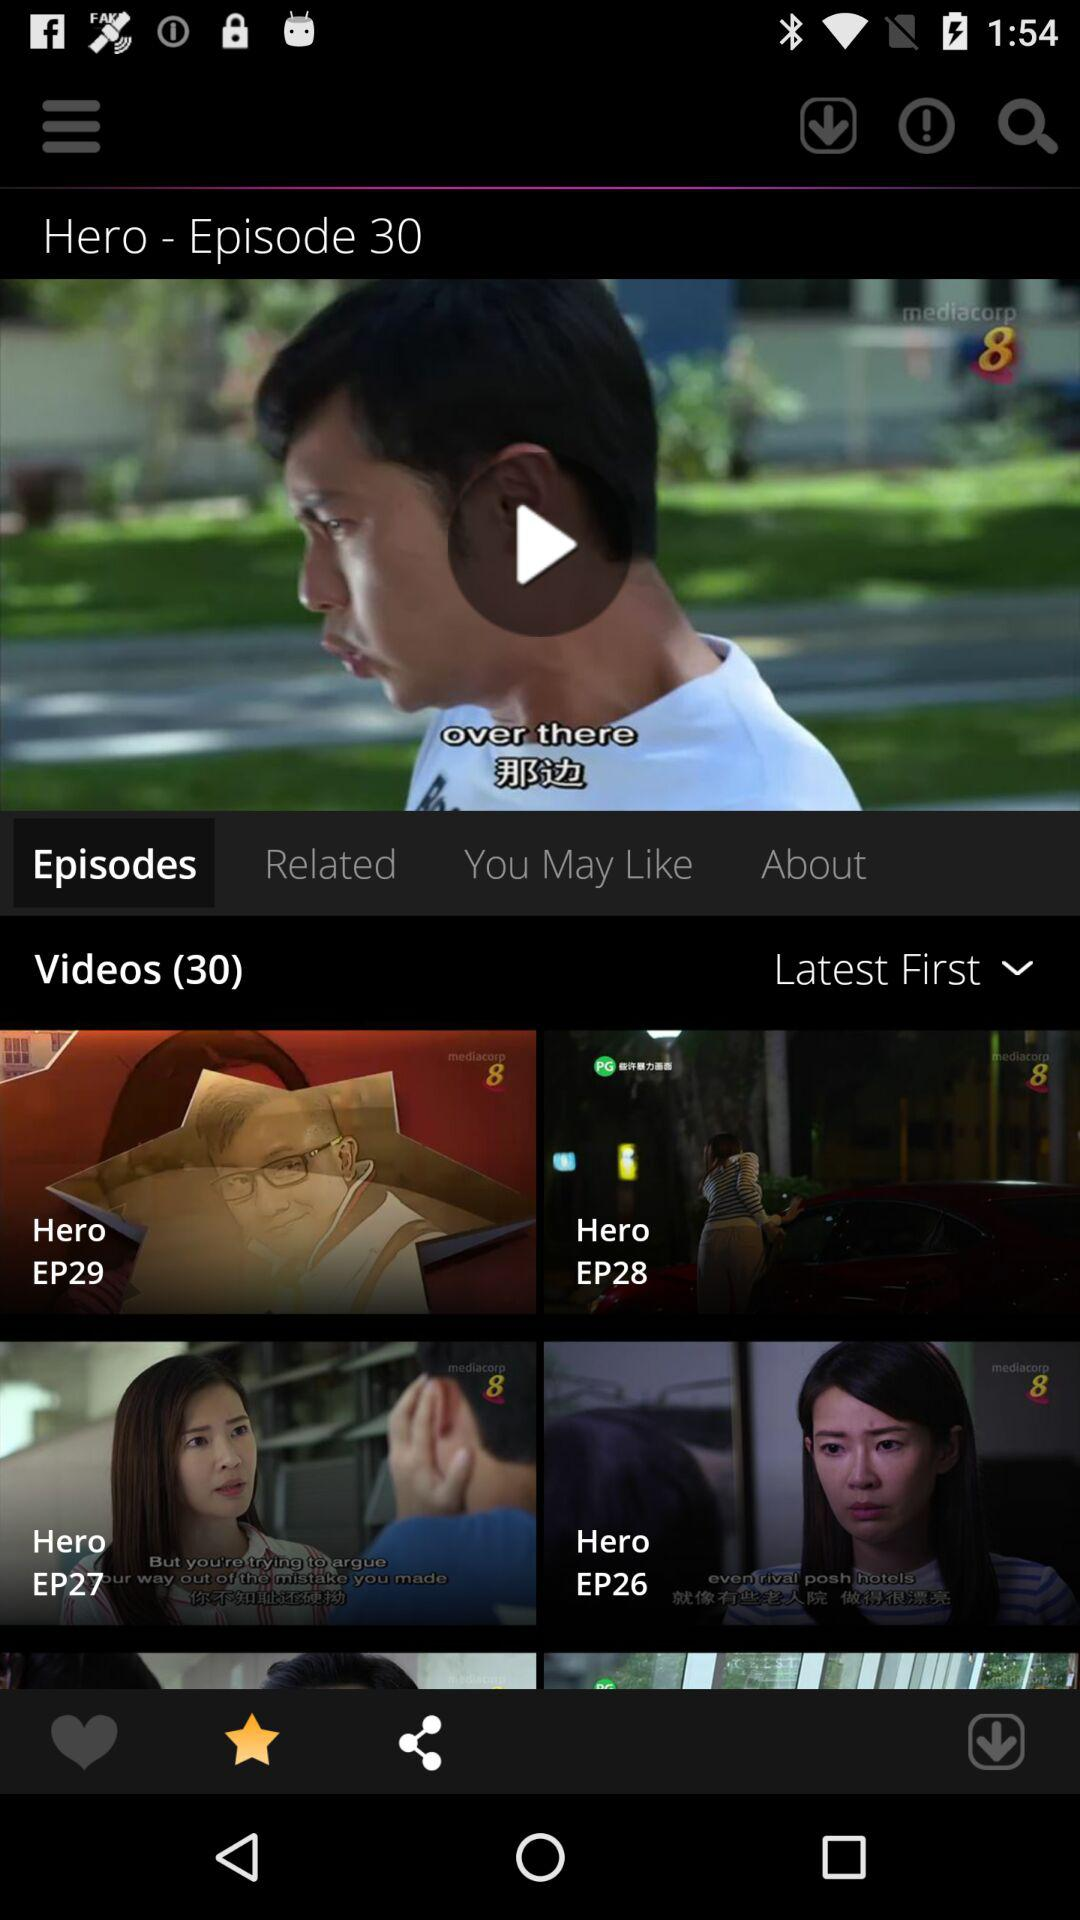Which episode of "Hero" are we on right now? You are on episode 30 of "Hero" right now. 